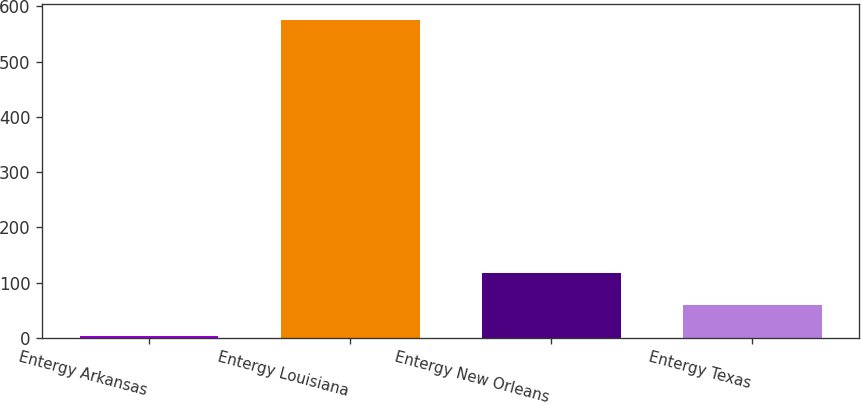Convert chart to OTSL. <chart><loc_0><loc_0><loc_500><loc_500><bar_chart><fcel>Entergy Arkansas<fcel>Entergy Louisiana<fcel>Entergy New Orleans<fcel>Entergy Texas<nl><fcel>2.6<fcel>575.8<fcel>117.24<fcel>59.92<nl></chart> 